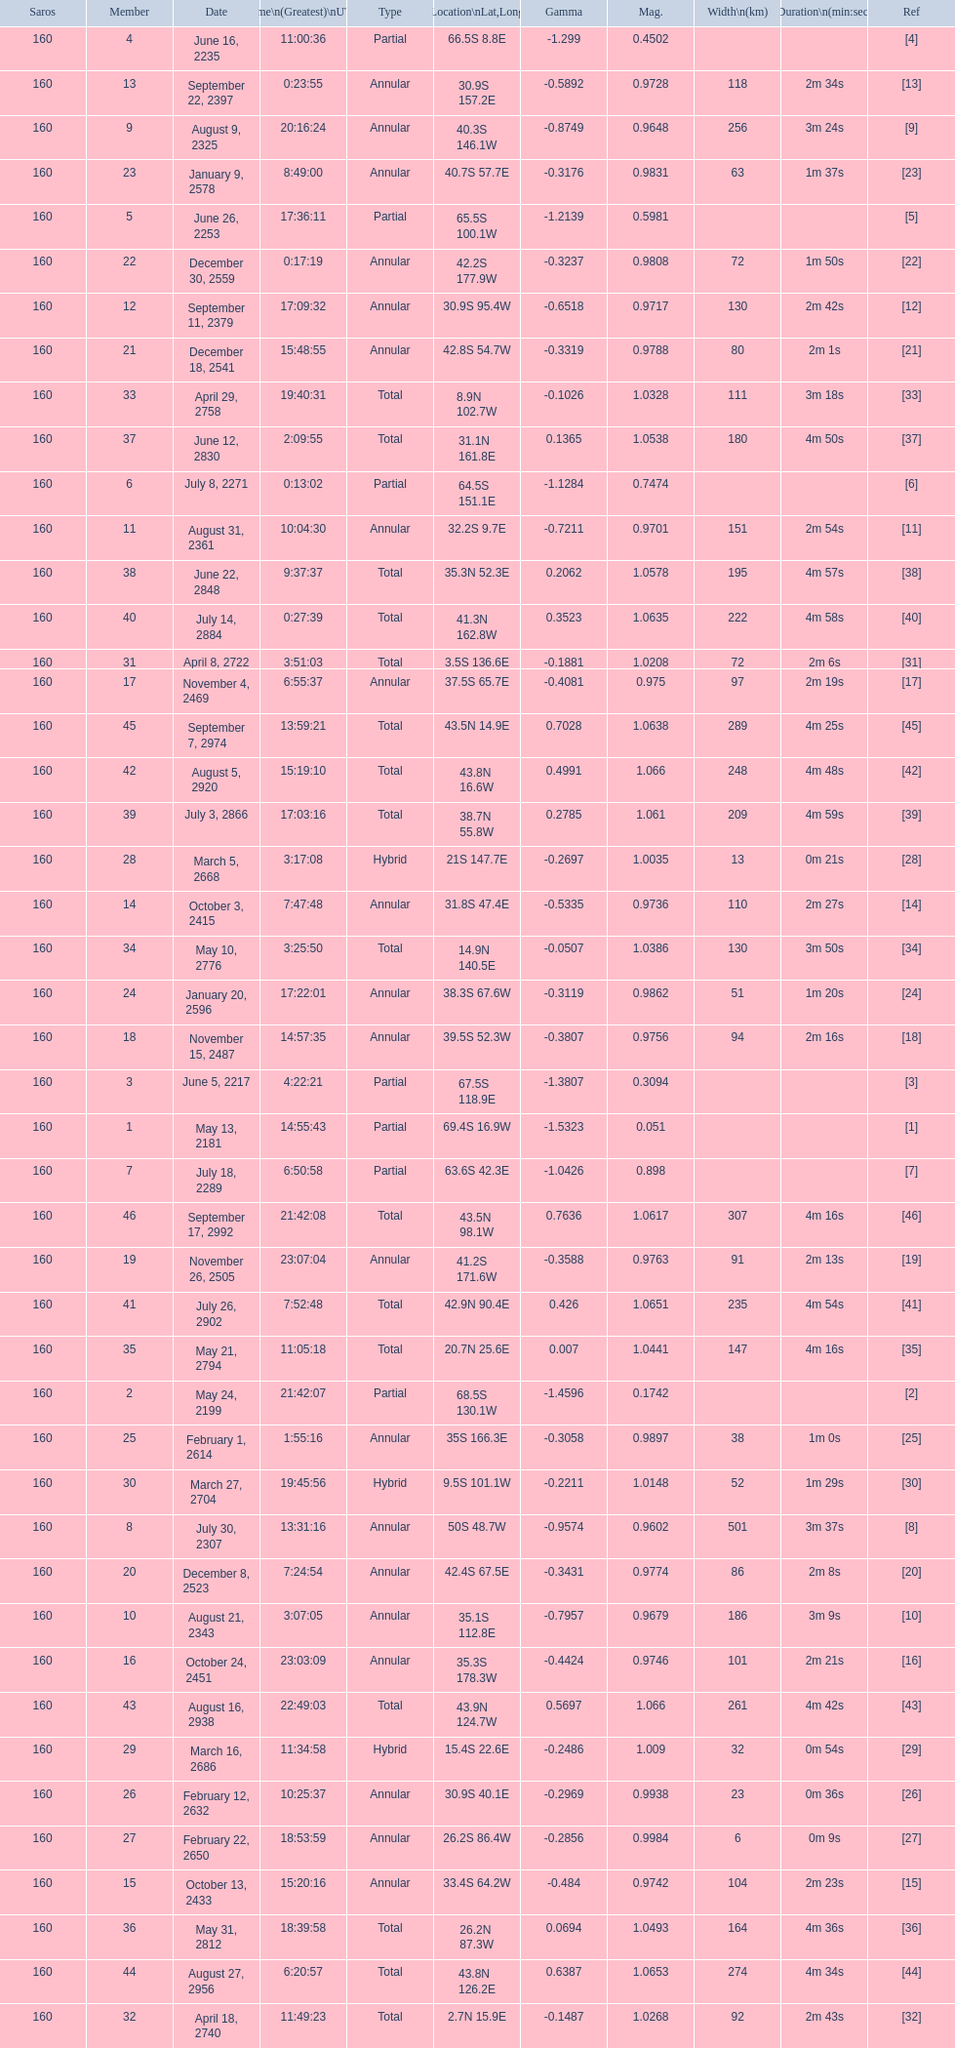How many partial members will occur before the first annular? 7. 